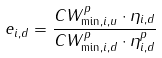<formula> <loc_0><loc_0><loc_500><loc_500>e _ { i , d } = \frac { C W ^ { p } _ { \min , i , u } \cdot \eta _ { i , d } } { C W ^ { p } _ { \min , i , d } \cdot \eta ^ { p } _ { i , d } }</formula> 